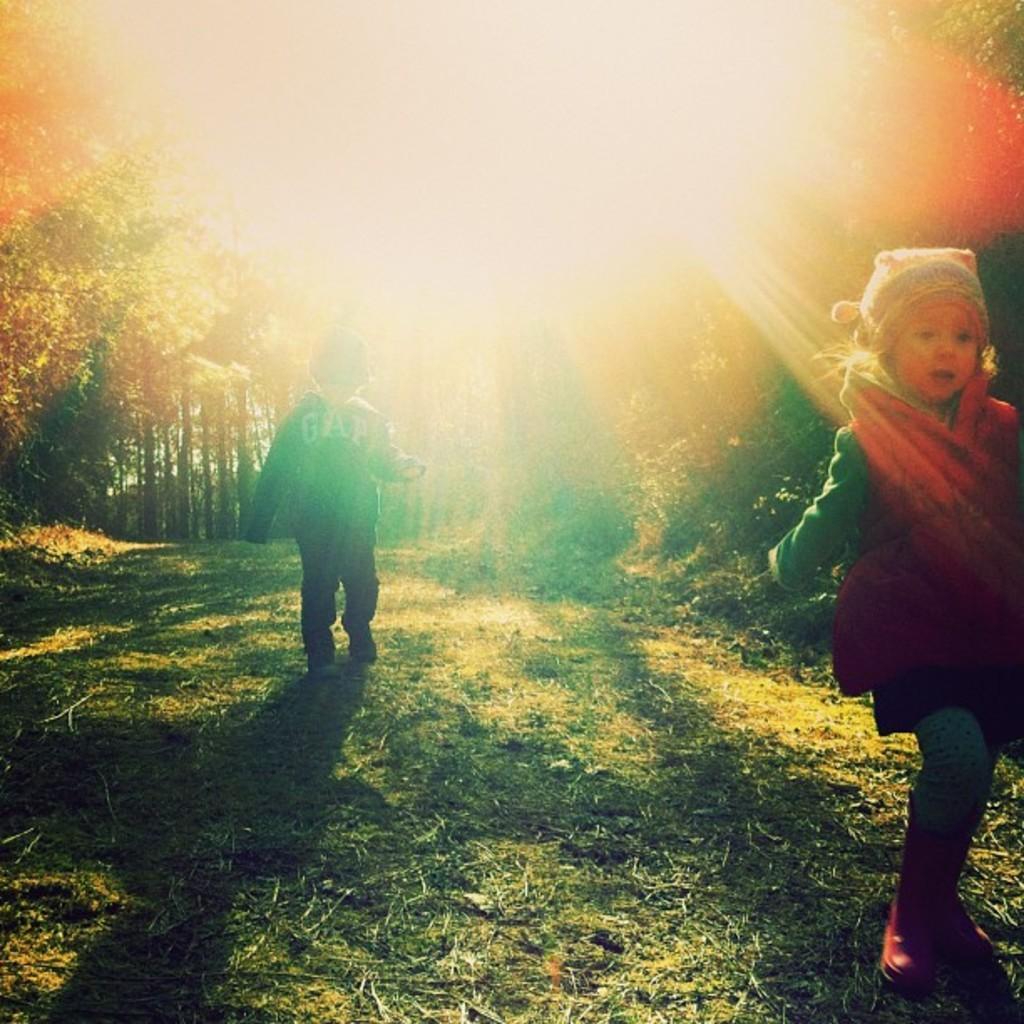Can you describe this image briefly? In this picture I can see, on the right side a girl is walking, she wore red color sweater. In the middle a boy is standing, at the back side there are trees, at the top it is the light. 